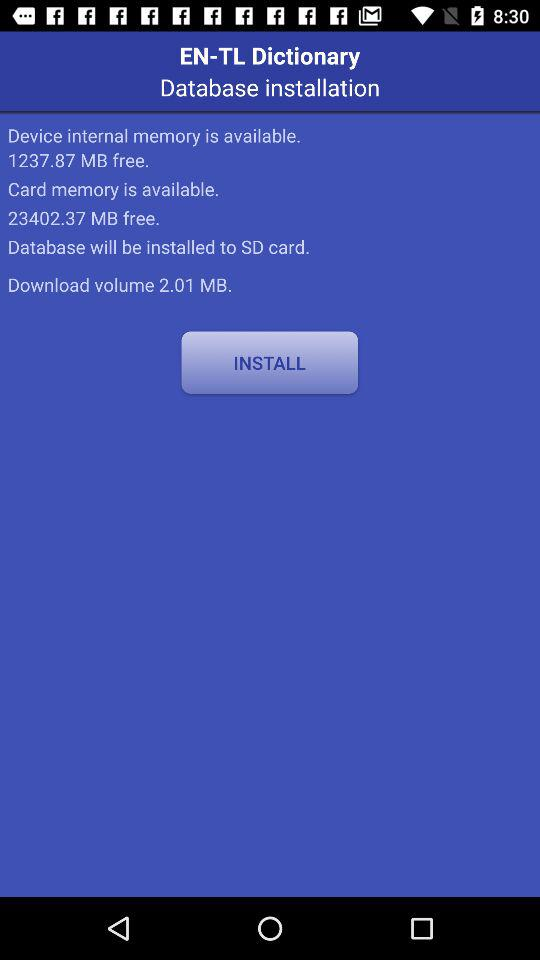How much more free space is there on the SD card than on the internal memory?
Answer the question using a single word or phrase. 22164.5 MB 